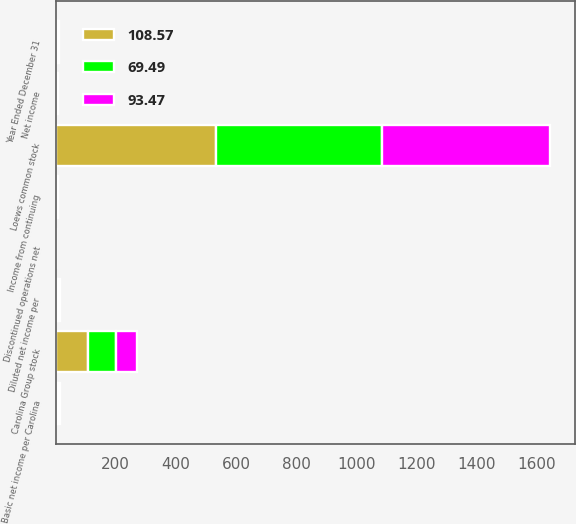Convert chart to OTSL. <chart><loc_0><loc_0><loc_500><loc_500><stacked_bar_chart><ecel><fcel>Year Ended December 31<fcel>Income from continuing<fcel>Discontinued operations net<fcel>Net income<fcel>Basic net income per Carolina<fcel>Diluted net income per<fcel>Loews common stock<fcel>Carolina Group stock<nl><fcel>108.57<fcel>3.77<fcel>3.65<fcel>0.01<fcel>3.66<fcel>4.92<fcel>4.91<fcel>534.79<fcel>108.43<nl><fcel>69.49<fcel>3.77<fcel>3.77<fcel>0.02<fcel>3.75<fcel>4.46<fcel>4.46<fcel>552.68<fcel>93.37<nl><fcel>93.47<fcel>3.77<fcel>1.67<fcel>0.05<fcel>1.72<fcel>3.62<fcel>3.62<fcel>557.1<fcel>69.4<nl></chart> 